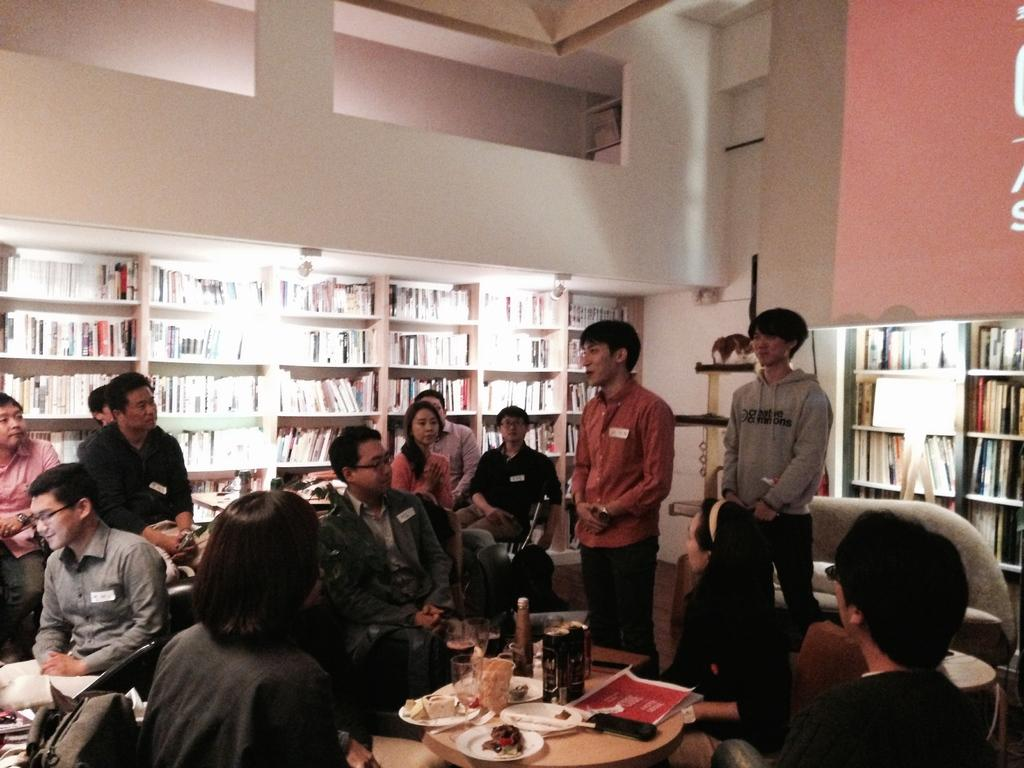Where was the image taken? The image was taken inside a room. How many people are visible in the image? There are many people in the image. What can be seen in the background of the image? There is a rack with books in the background. What is located to the right in the image? There is a wall to the right. What arithmetic problem is being solved by the boys in the image? There are no boys or arithmetic problems visible in the image. What word is being emphasized by the people in the image? There is no specific word being emphasized by the people in the image. 